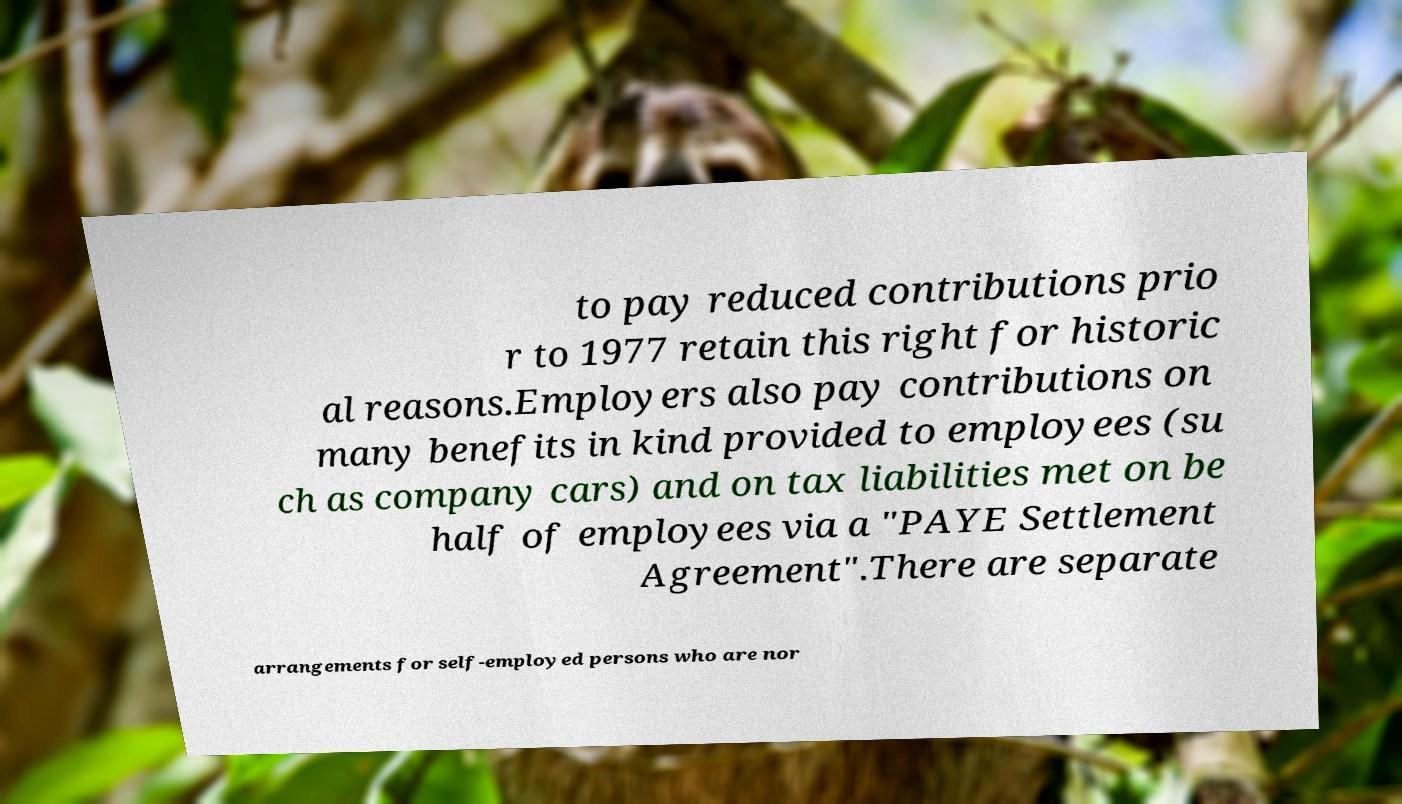Can you accurately transcribe the text from the provided image for me? to pay reduced contributions prio r to 1977 retain this right for historic al reasons.Employers also pay contributions on many benefits in kind provided to employees (su ch as company cars) and on tax liabilities met on be half of employees via a "PAYE Settlement Agreement".There are separate arrangements for self-employed persons who are nor 